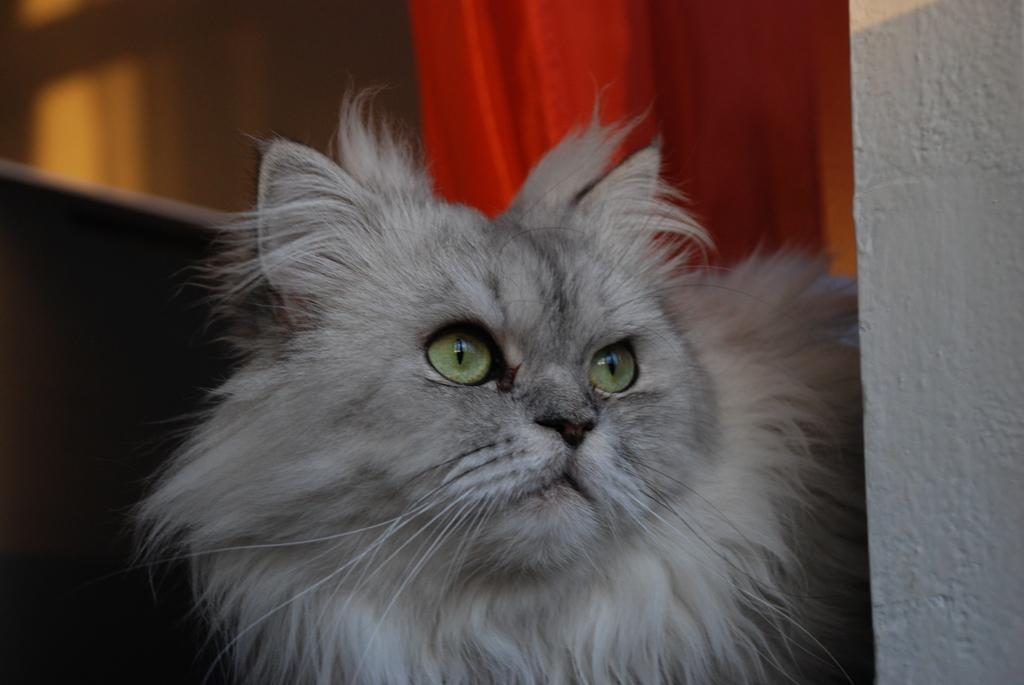What is the main subject in the foreground of the image? There is a cat in the foreground of the image. What can be seen in the background of the image? There is a couch in the background of the image. What is associated with the couch in the image? There are curtains associated with the couch. What is located on the right side of the image? There is a wall on the right side of the image. How many chickens are sitting on the icicle in the image? There are no chickens or icicles present in the image. 